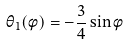<formula> <loc_0><loc_0><loc_500><loc_500>\theta _ { 1 } ( \phi ) = - \frac { 3 } { 4 } \sin \phi</formula> 